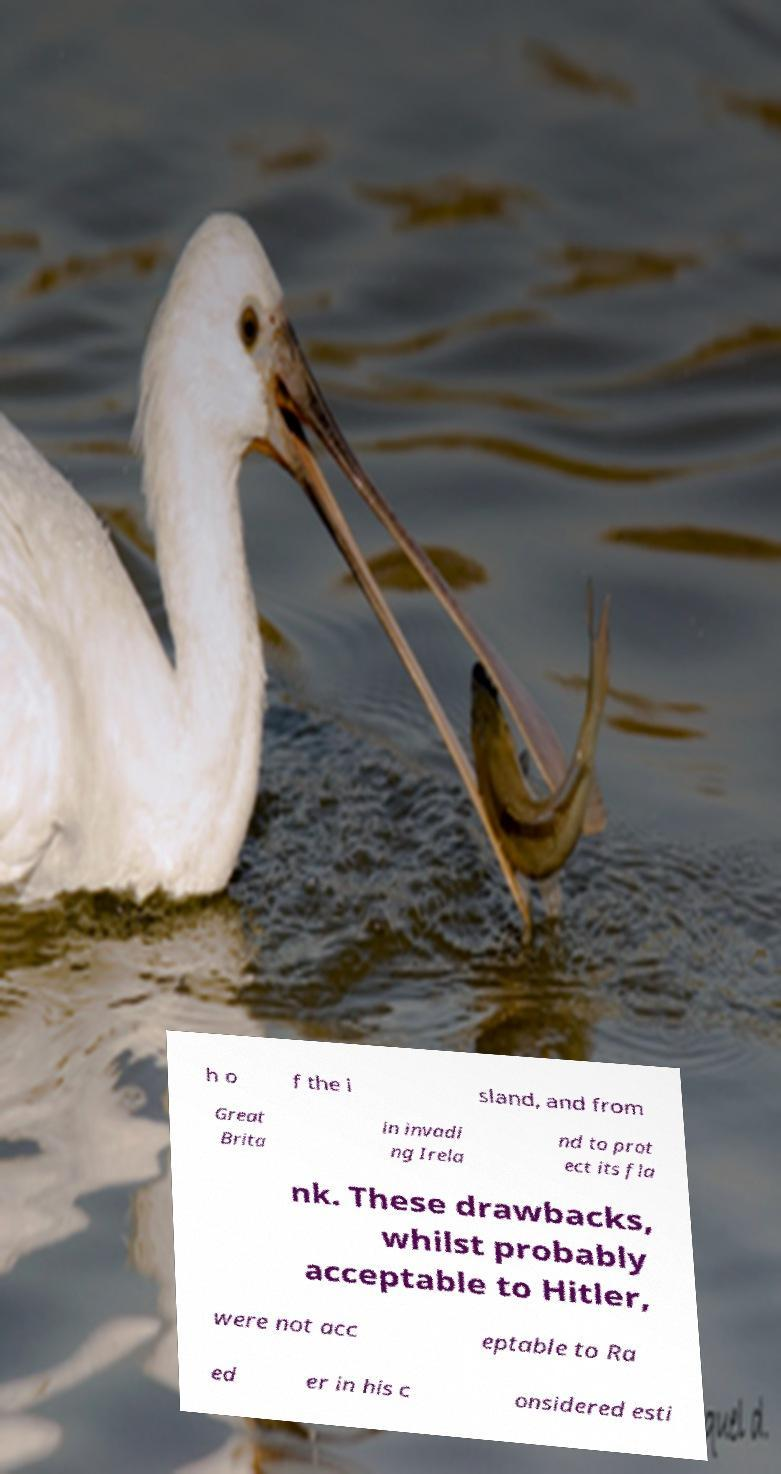Can you read and provide the text displayed in the image?This photo seems to have some interesting text. Can you extract and type it out for me? h o f the i sland, and from Great Brita in invadi ng Irela nd to prot ect its fla nk. These drawbacks, whilst probably acceptable to Hitler, were not acc eptable to Ra ed er in his c onsidered esti 